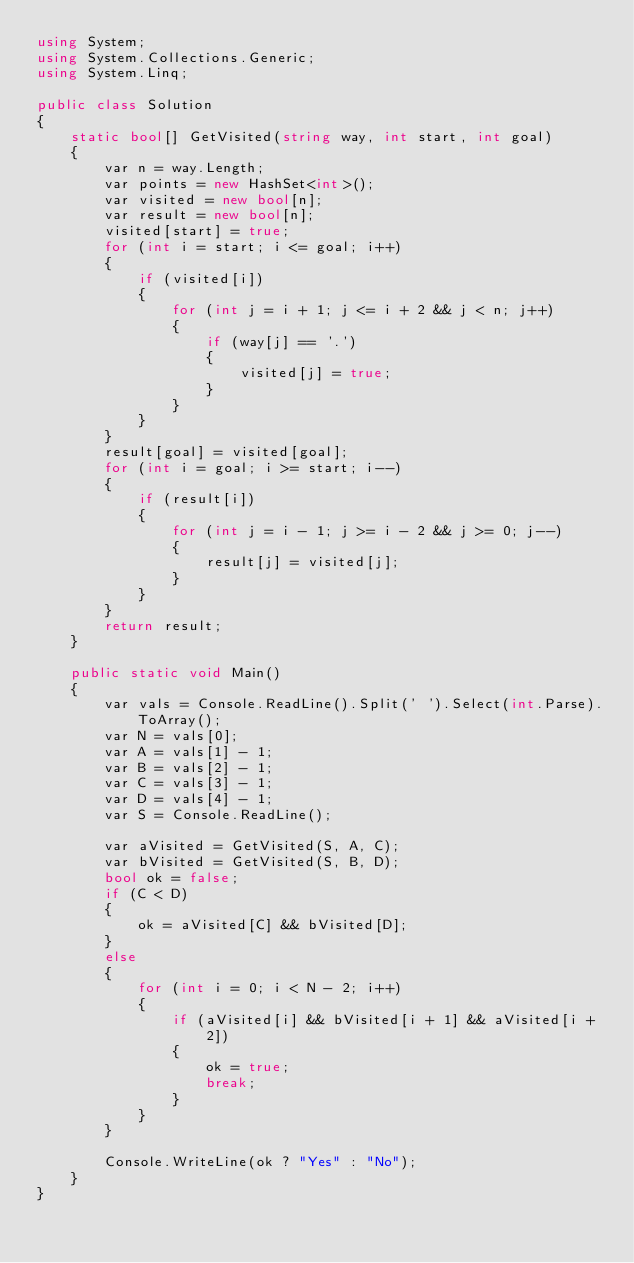Convert code to text. <code><loc_0><loc_0><loc_500><loc_500><_C#_>using System;
using System.Collections.Generic;
using System.Linq;

public class Solution
{
    static bool[] GetVisited(string way, int start, int goal)
    {
        var n = way.Length;
        var points = new HashSet<int>();
        var visited = new bool[n];
        var result = new bool[n];
        visited[start] = true;
        for (int i = start; i <= goal; i++)
        {
            if (visited[i])
            {
                for (int j = i + 1; j <= i + 2 && j < n; j++)
                {
                    if (way[j] == '.')
                    {
                        visited[j] = true;
                    }
                }
            }
        }
        result[goal] = visited[goal];
        for (int i = goal; i >= start; i--)
        {
            if (result[i])
            {
                for (int j = i - 1; j >= i - 2 && j >= 0; j--)
                {
                    result[j] = visited[j];
                }
            }
        }
        return result;
    }

    public static void Main()
    {
        var vals = Console.ReadLine().Split(' ').Select(int.Parse).ToArray();
        var N = vals[0];
        var A = vals[1] - 1;
        var B = vals[2] - 1;
        var C = vals[3] - 1;
        var D = vals[4] - 1;
        var S = Console.ReadLine();

        var aVisited = GetVisited(S, A, C);
        var bVisited = GetVisited(S, B, D);
        bool ok = false;
        if (C < D)
        {
            ok = aVisited[C] && bVisited[D];
        }
        else
        {
            for (int i = 0; i < N - 2; i++)
            {
                if (aVisited[i] && bVisited[i + 1] && aVisited[i + 2])
                {
                    ok = true;
                    break;
                }
            }
        }

        Console.WriteLine(ok ? "Yes" : "No");
    }
}</code> 